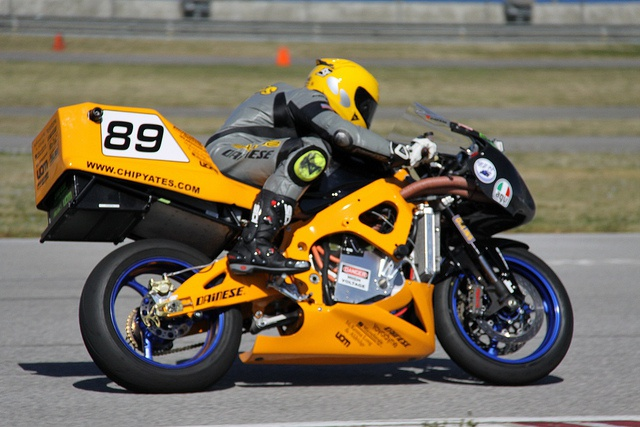Describe the objects in this image and their specific colors. I can see motorcycle in darkgray, black, orange, and gray tones and people in darkgray, black, gray, and gold tones in this image. 